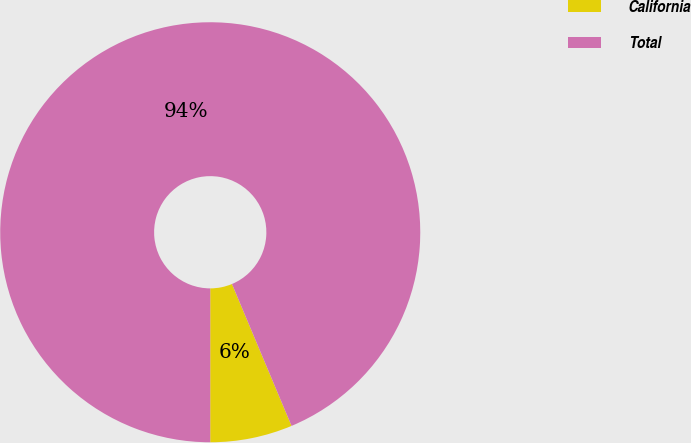Convert chart to OTSL. <chart><loc_0><loc_0><loc_500><loc_500><pie_chart><fcel>California<fcel>Total<nl><fcel>6.33%<fcel>93.67%<nl></chart> 